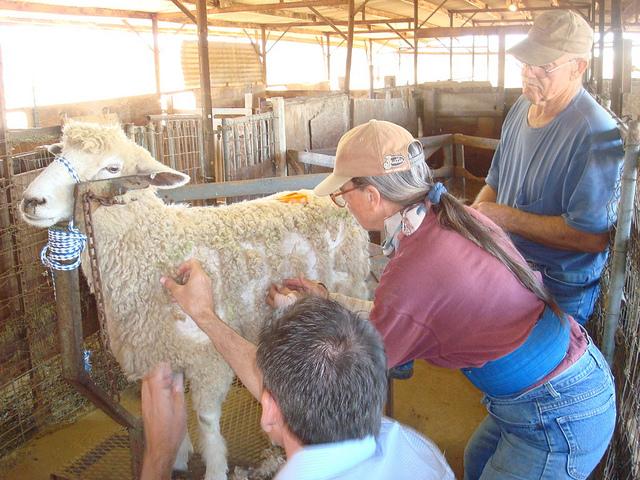How many people are wearing hats?
Quick response, please. 2. What is the blue item above the lady's waist?
Answer briefly. Brace. What kind of animal is this?
Short answer required. Sheep. 